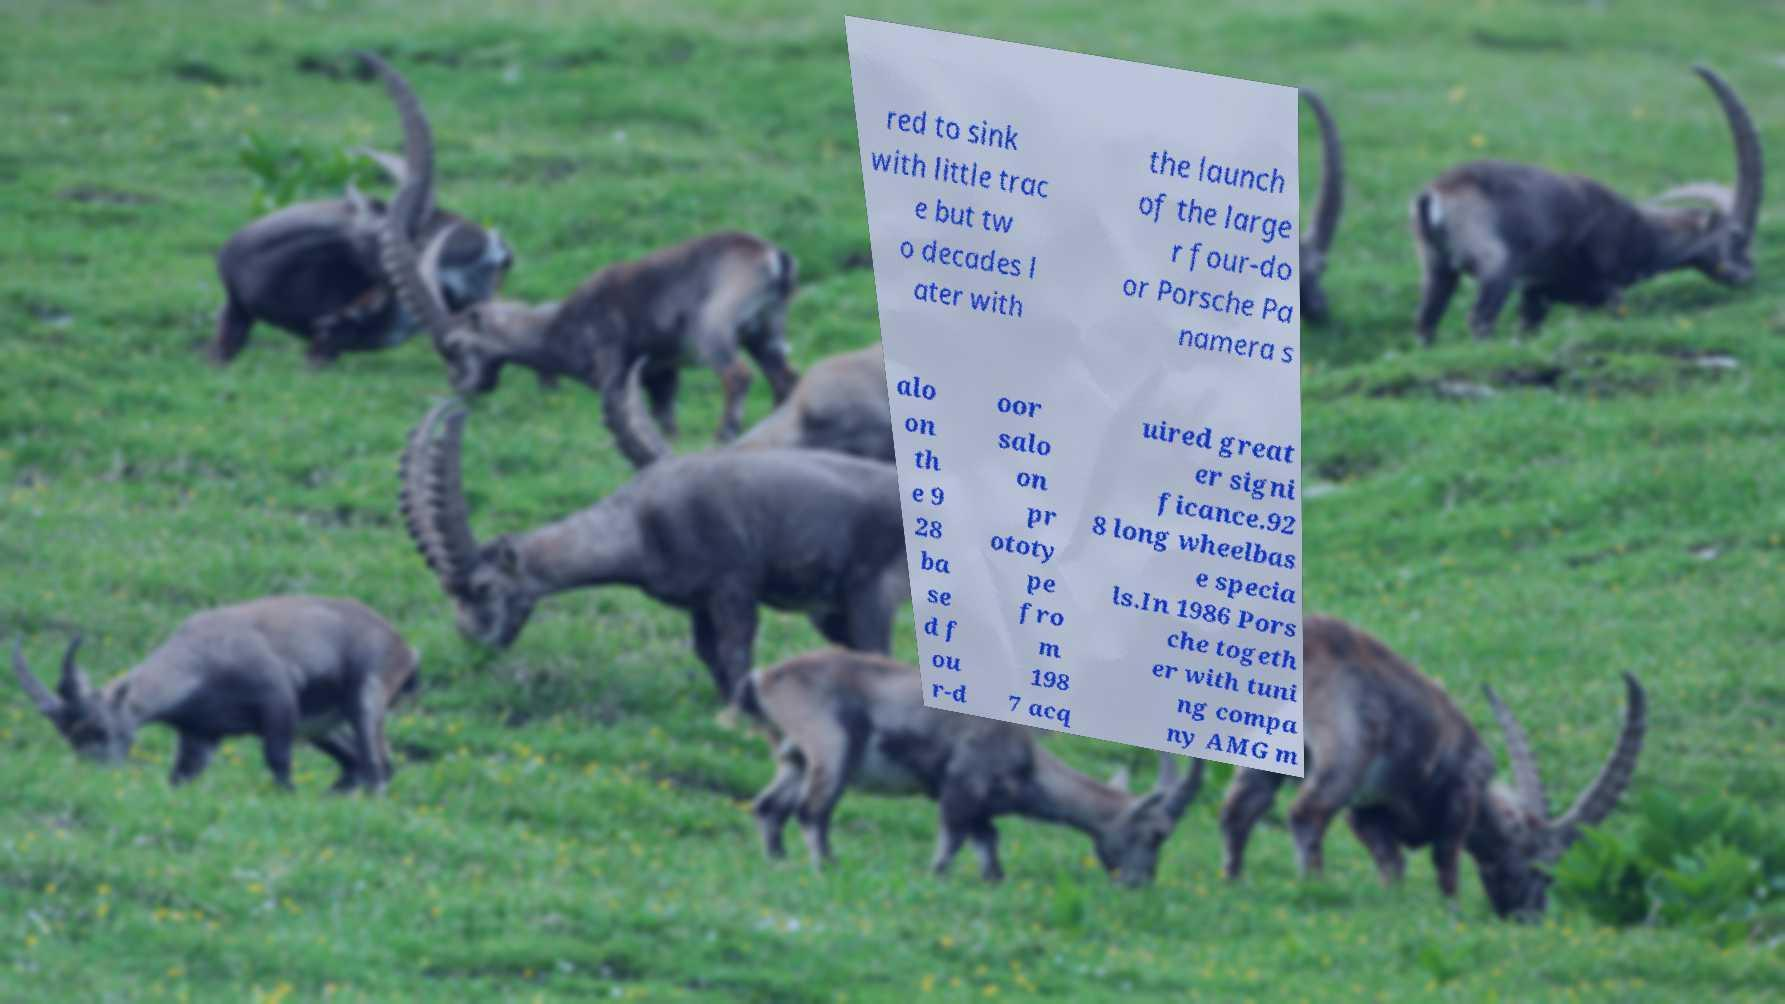Can you read and provide the text displayed in the image?This photo seems to have some interesting text. Can you extract and type it out for me? red to sink with little trac e but tw o decades l ater with the launch of the large r four-do or Porsche Pa namera s alo on th e 9 28 ba se d f ou r-d oor salo on pr ototy pe fro m 198 7 acq uired great er signi ficance.92 8 long wheelbas e specia ls.In 1986 Pors che togeth er with tuni ng compa ny AMG m 